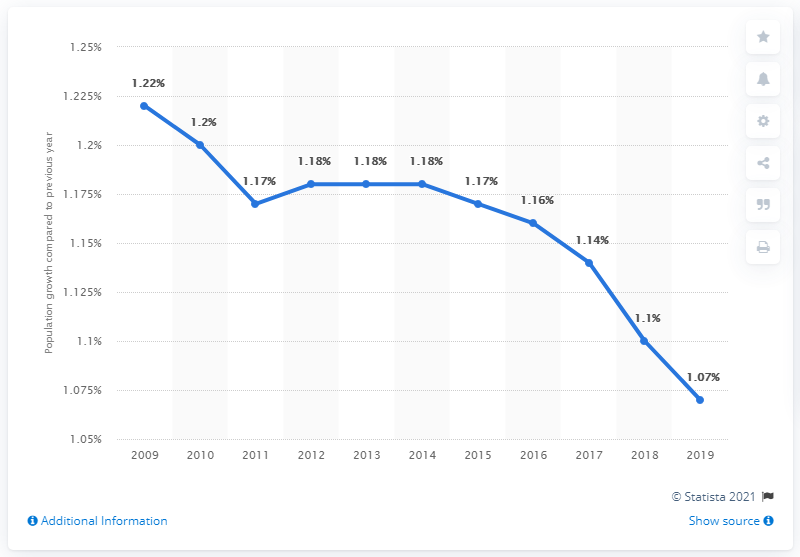Draw attention to some important aspects in this diagram. In 2019, the global population increased by 1.07% compared to the previous year. 